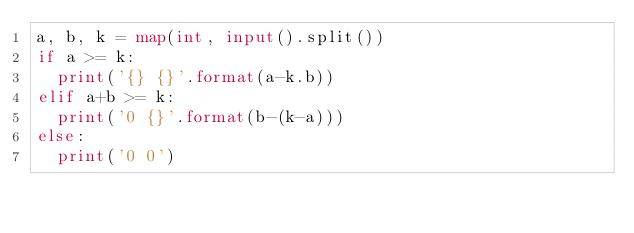<code> <loc_0><loc_0><loc_500><loc_500><_Python_>a, b, k = map(int, input().split())
if a >= k:
  print('{} {}'.format(a-k.b))
elif a+b >= k:
  print('0 {}'.format(b-(k-a)))
else:
  print('0 0')
</code> 